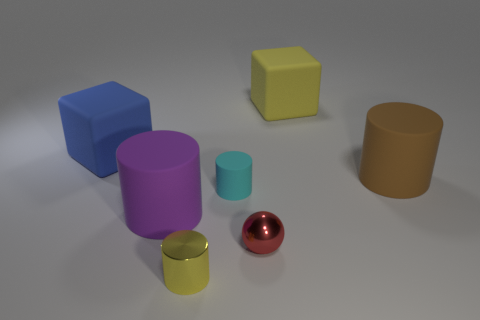Subtract all cyan cylinders. How many cylinders are left? 3 Subtract all green cylinders. Subtract all brown cubes. How many cylinders are left? 4 Add 1 large gray shiny balls. How many objects exist? 8 Subtract all cylinders. How many objects are left? 3 Add 3 tiny red shiny cubes. How many tiny red shiny cubes exist? 3 Subtract 0 brown balls. How many objects are left? 7 Subtract all shiny cylinders. Subtract all small cylinders. How many objects are left? 4 Add 1 yellow cylinders. How many yellow cylinders are left? 2 